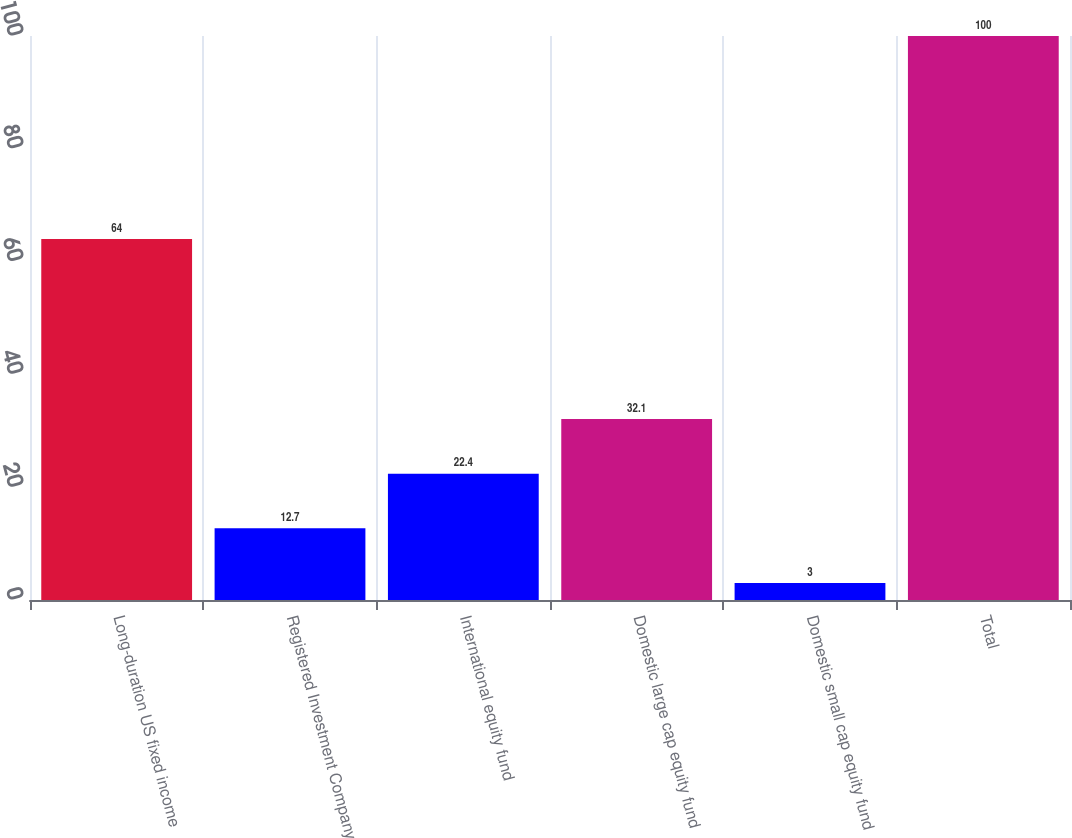<chart> <loc_0><loc_0><loc_500><loc_500><bar_chart><fcel>Long-duration US fixed income<fcel>Registered Investment Company<fcel>International equity fund<fcel>Domestic large cap equity fund<fcel>Domestic small cap equity fund<fcel>Total<nl><fcel>64<fcel>12.7<fcel>22.4<fcel>32.1<fcel>3<fcel>100<nl></chart> 